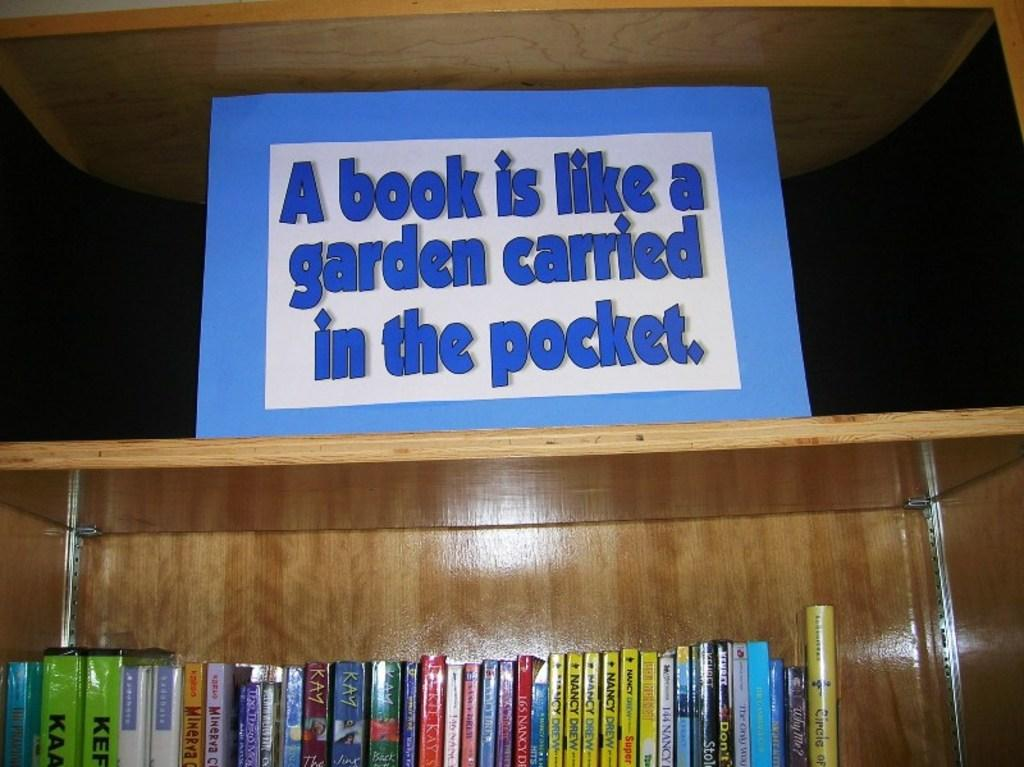<image>
Present a compact description of the photo's key features. a sign on a shelf saying a book is like a garden carried in the pocket 